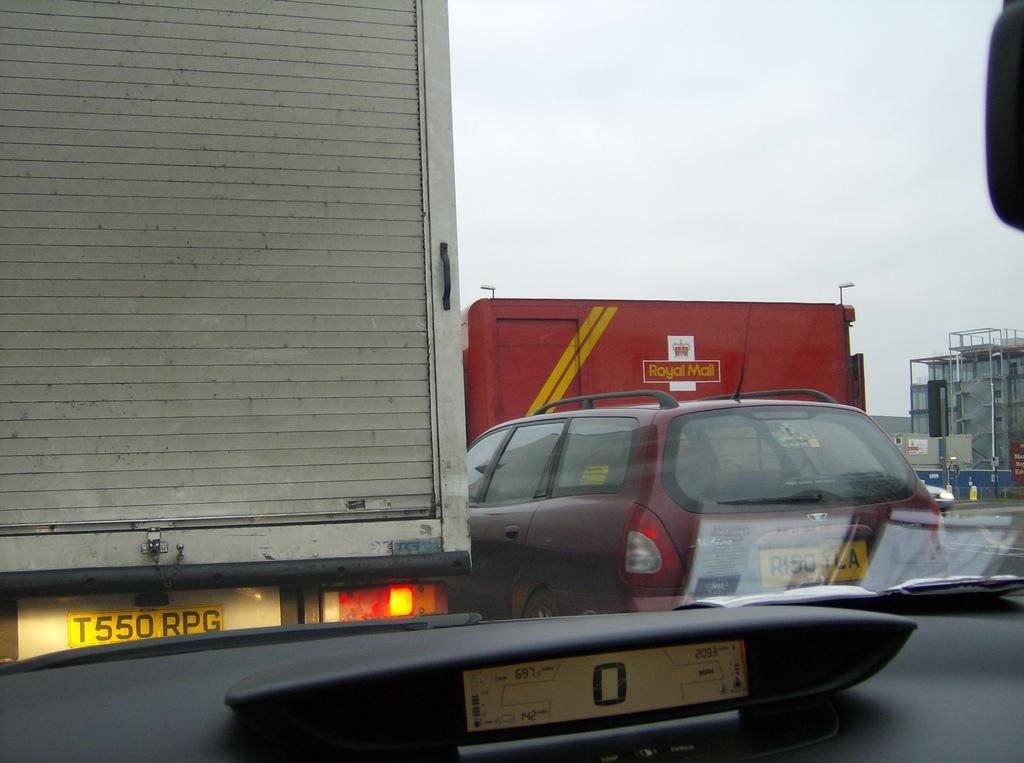What can be seen on the road in the image? There are vehicles on the road in the image. What type of structure is visible in the image? There is a building visible in the image. What is visible in the background of the image? The sky is visible in the background of the image. How many chickens are being washed with soap in the image? There are no chickens or soap present in the image. What type of observation can be made about the vehicles on the road in the image? The provided facts do not include any information about the vehicles' speed, direction, or any other observation that could be made about them. 